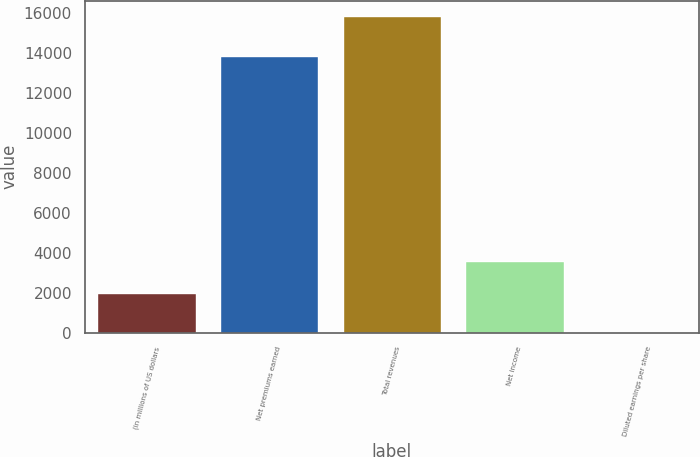<chart> <loc_0><loc_0><loc_500><loc_500><bar_chart><fcel>(in millions of US dollars<fcel>Net premiums earned<fcel>Total revenues<fcel>Net income<fcel>Diluted earnings per share<nl><fcel>2007<fcel>13823<fcel>15830<fcel>3589.18<fcel>8.2<nl></chart> 